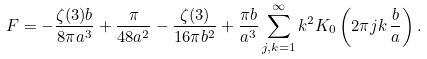<formula> <loc_0><loc_0><loc_500><loc_500>F = - \frac { \zeta ( 3 ) b } { 8 \pi a ^ { 3 } } + \frac { \pi } { 4 8 a ^ { 2 } } - \frac { \zeta ( 3 ) } { 1 6 \pi b ^ { 2 } } + \frac { \pi b } { a ^ { 3 } } \sum _ { j , k = 1 } ^ { \infty } k ^ { 2 } K _ { 0 } \left ( 2 \pi j k \, \frac { b } { a } \right ) .</formula> 